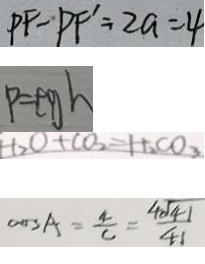<formula> <loc_0><loc_0><loc_500><loc_500>P F - P F ^ { \prime } = 2 a = 4 
 P = \rho g h 
 t _ { 2 } O + C O _ { 3 } = H _ { 2 } C O _ { 3 } 
 \cos A = \frac { 4 } { c } = \frac { 4 \sqrt { 4 1 } } { 4 1 }</formula> 